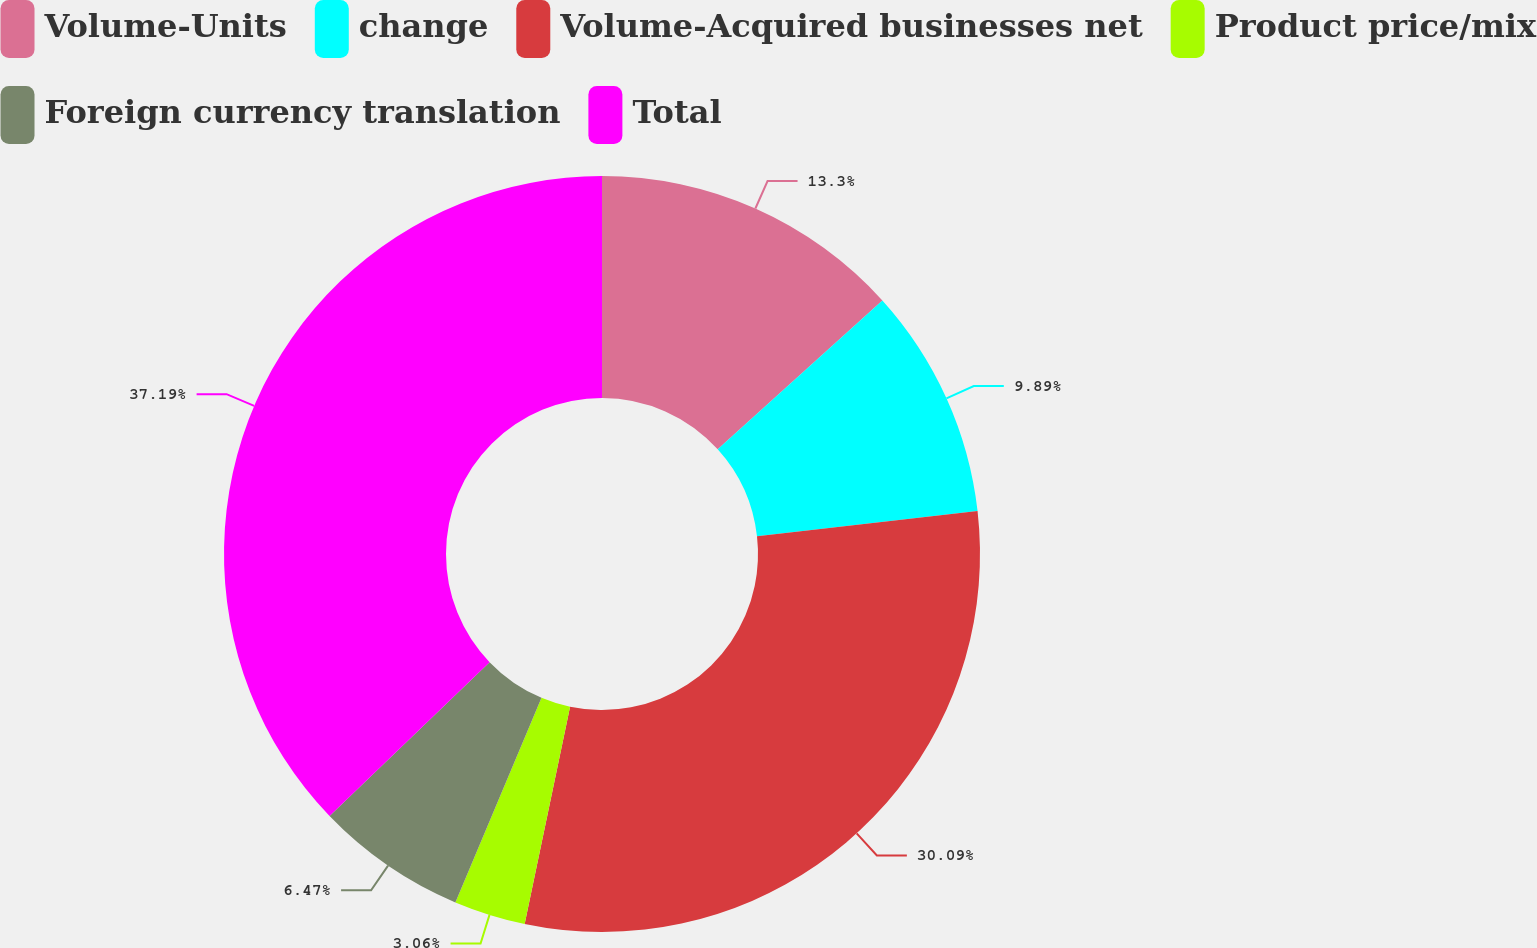Convert chart to OTSL. <chart><loc_0><loc_0><loc_500><loc_500><pie_chart><fcel>Volume-Units<fcel>change<fcel>Volume-Acquired businesses net<fcel>Product price/mix<fcel>Foreign currency translation<fcel>Total<nl><fcel>13.3%<fcel>9.89%<fcel>30.09%<fcel>3.06%<fcel>6.47%<fcel>37.19%<nl></chart> 